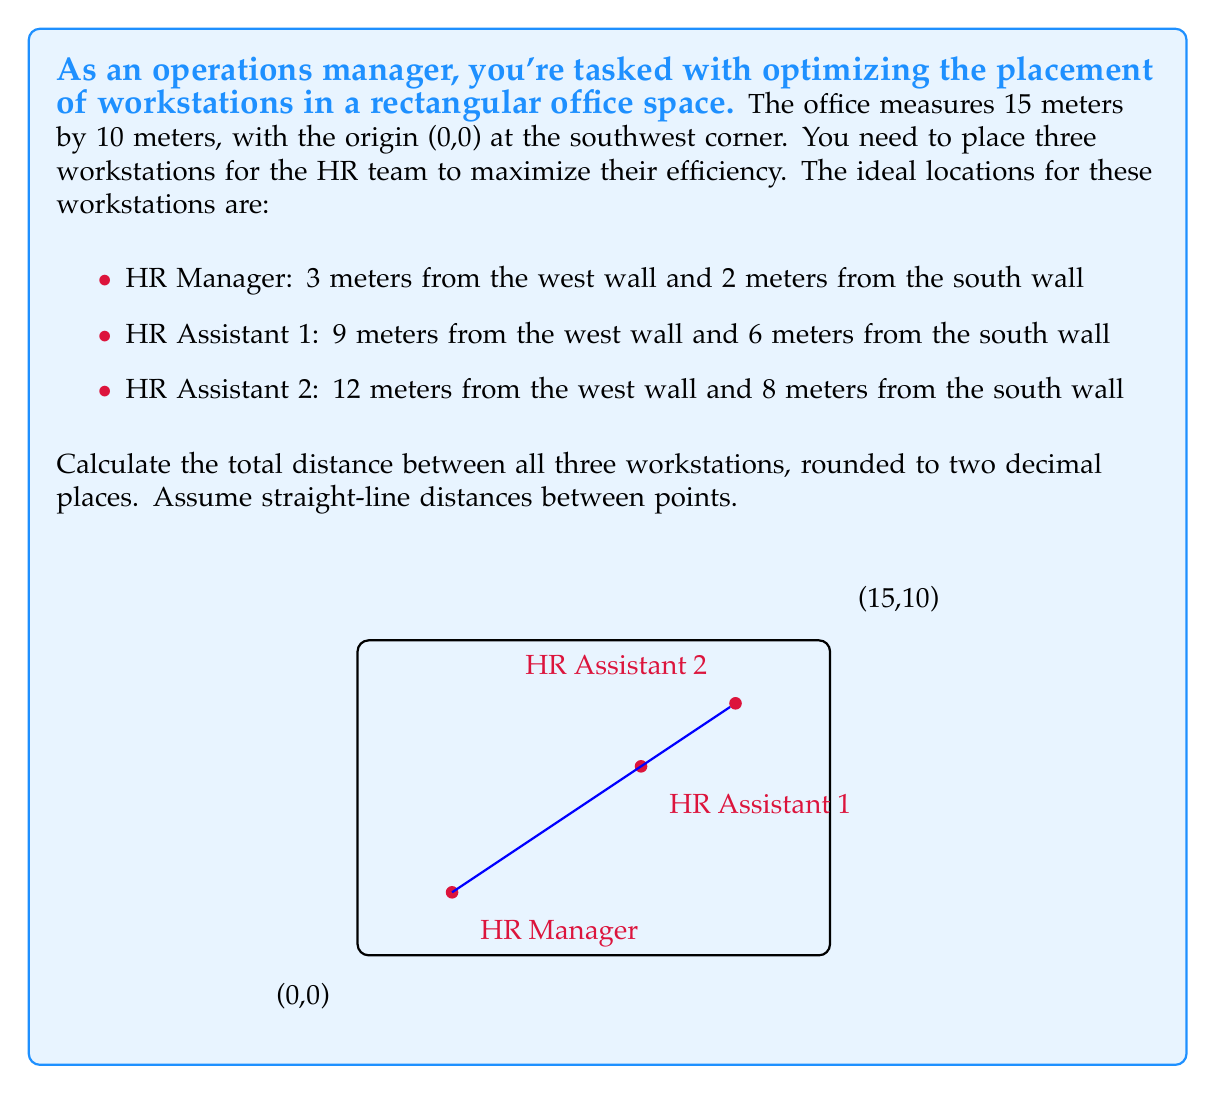Show me your answer to this math problem. To solve this problem, we need to:
1. Identify the coordinates of each workstation
2. Calculate the distance between each pair of workstations
3. Sum up all distances

Step 1: Identify coordinates
- HR Manager: (3, 2)
- HR Assistant 1: (9, 6)
- HR Assistant 2: (12, 8)

Step 2: Calculate distances
We'll use the distance formula: $d = \sqrt{(x_2-x_1)^2 + (y_2-y_1)^2}$

a) Distance between HR Manager and HR Assistant 1:
$$d_1 = \sqrt{(9-3)^2 + (6-2)^2} = \sqrt{36 + 16} = \sqrt{52} \approx 7.21$$

b) Distance between HR Assistant 1 and HR Assistant 2:
$$d_2 = \sqrt{(12-9)^2 + (8-6)^2} = \sqrt{9 + 4} = \sqrt{13} \approx 3.61$$

c) Distance between HR Manager and HR Assistant 2:
$$d_3 = \sqrt{(12-3)^2 + (8-2)^2} = \sqrt{81 + 36} = \sqrt{117} \approx 10.82$$

Step 3: Sum up all distances
Total distance = $d_1 + d_2 + d_3 = 7.21 + 3.61 + 10.82 = 21.64$ meters

Rounding to two decimal places, we get 21.64 meters.
Answer: 21.64 meters 